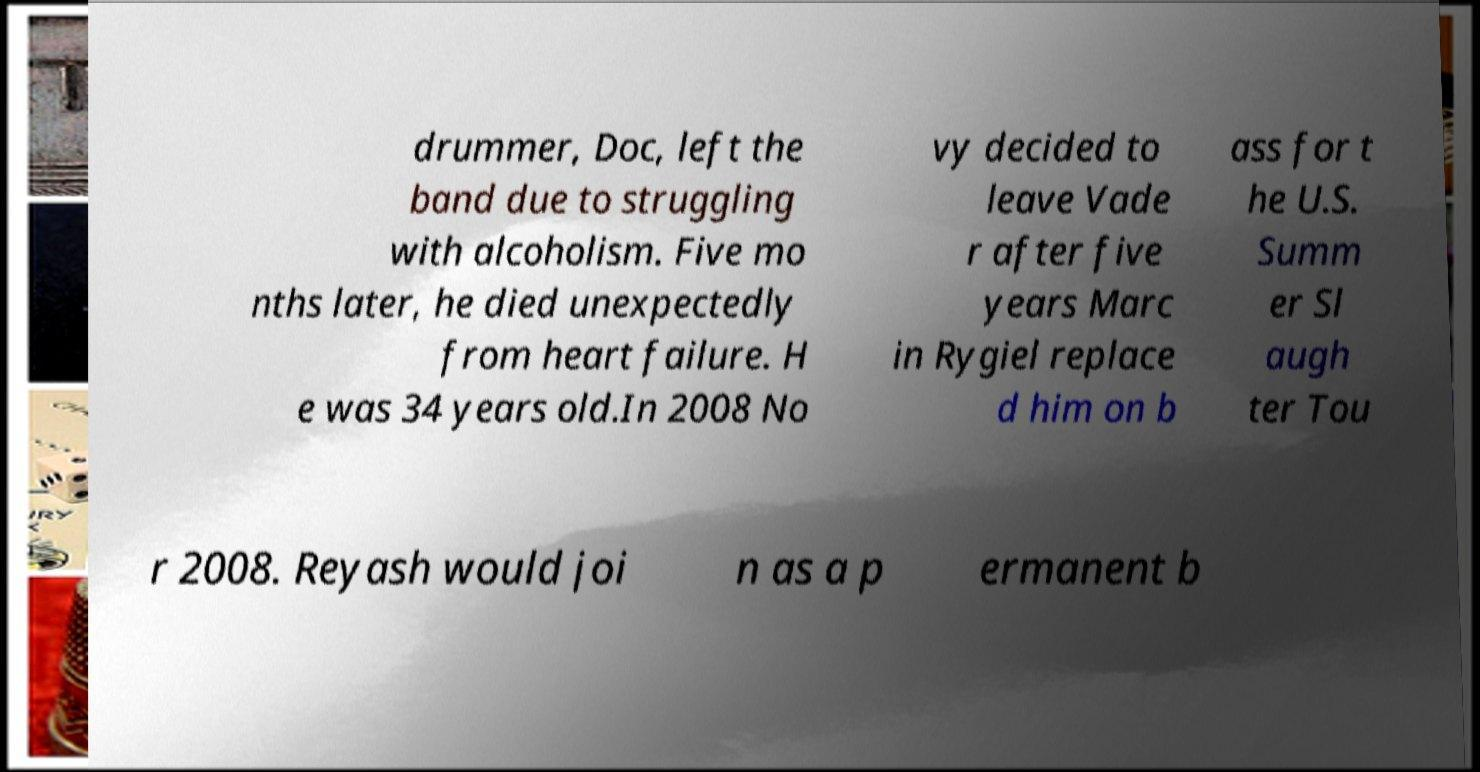There's text embedded in this image that I need extracted. Can you transcribe it verbatim? drummer, Doc, left the band due to struggling with alcoholism. Five mo nths later, he died unexpectedly from heart failure. H e was 34 years old.In 2008 No vy decided to leave Vade r after five years Marc in Rygiel replace d him on b ass for t he U.S. Summ er Sl augh ter Tou r 2008. Reyash would joi n as a p ermanent b 